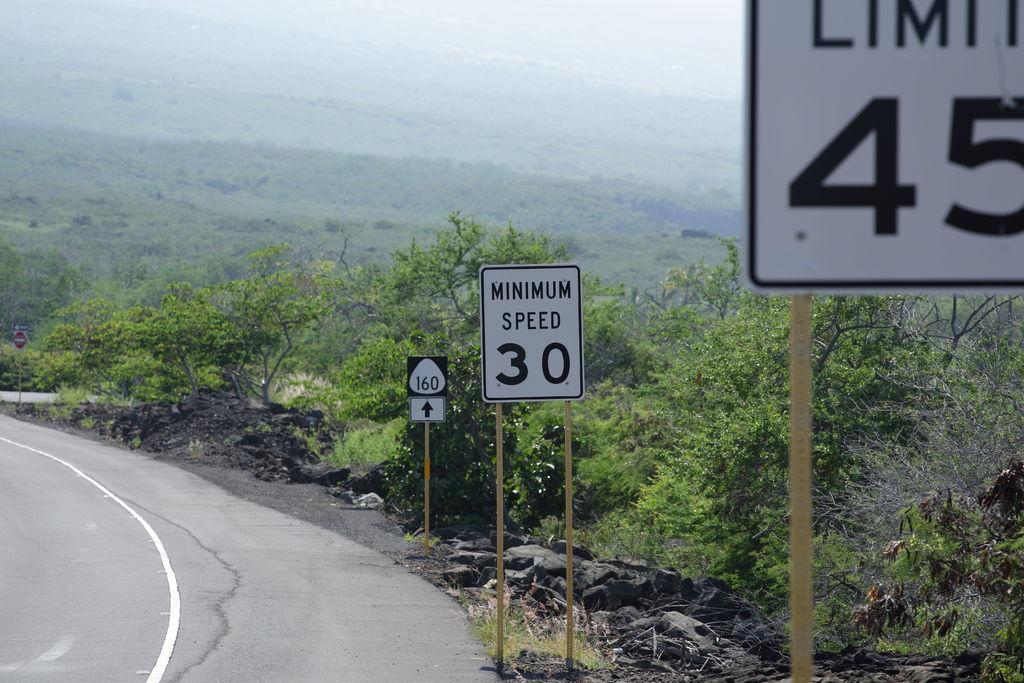What is located on the right side of the image? There is a road on the right side of the image. What else can be seen on the right side of the image? There are many sign boards on the right side of the image. What is visible in the background of the image? There are trees and hills in the background of the image. What type of blade can be seen in the hands of the writer in the image? There is no writer or blade present in the image. What color is the marble used to create the sculpture in the image? There is no sculpture or marble present in the image. 